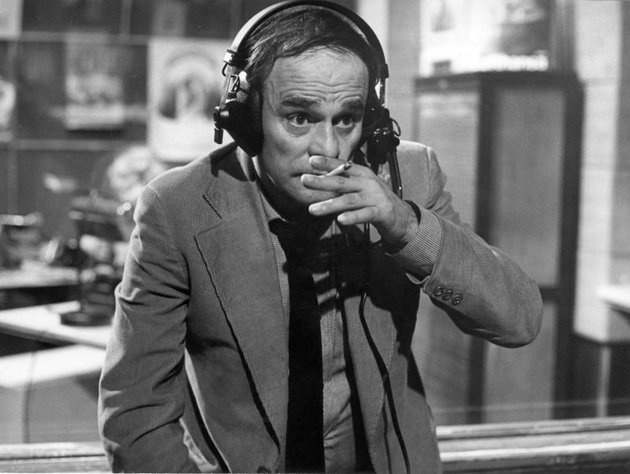Can you tell me more about this man's role in the radio studio? The man in the image appears to be a radio DJ, deeply engrossed in his job. With a formal suit and a cigarette in his hand, he embodies the classic, somewhat glamorous image of a mid-20th century radio personality. His headphones and proximity to the microphone indicate he is likely in the midst of broadcasting a live show or preparing to go on-air. The surrounding studio equipment and posters suggest a vibrant, busy environment where diverse content is created and shared with the audience. What kind of programs do you think he might be broadcasting? Given his formal attire and focused demeanor, he might be hosting a variety of programs, ranging from music shows to interviews, news segments, or even talk shows. The presence of posters could hint at a radio station that offers cultural content, possibly music from different genres, theatrical productions, or political discussions. His persona and the studio setting suggest a versatile DJ capable of engaging his audience with diverse content. Why do you think there are posters on the wall? Do they have any specific significance? The posters on the wall likely serve multiple purposes. They could be promotional material for upcoming shows or events, providing a visual element that enhances the studio's atmosphere. They might also reflect the DJ's interests or the station's partnerships and collaborations, showcasing a cultural and artistic dimension to their work. Additionally, they could serve as inspiration or a reminder of the diverse programs and content the station produces, contributing to a creative and dynamic work environment. 